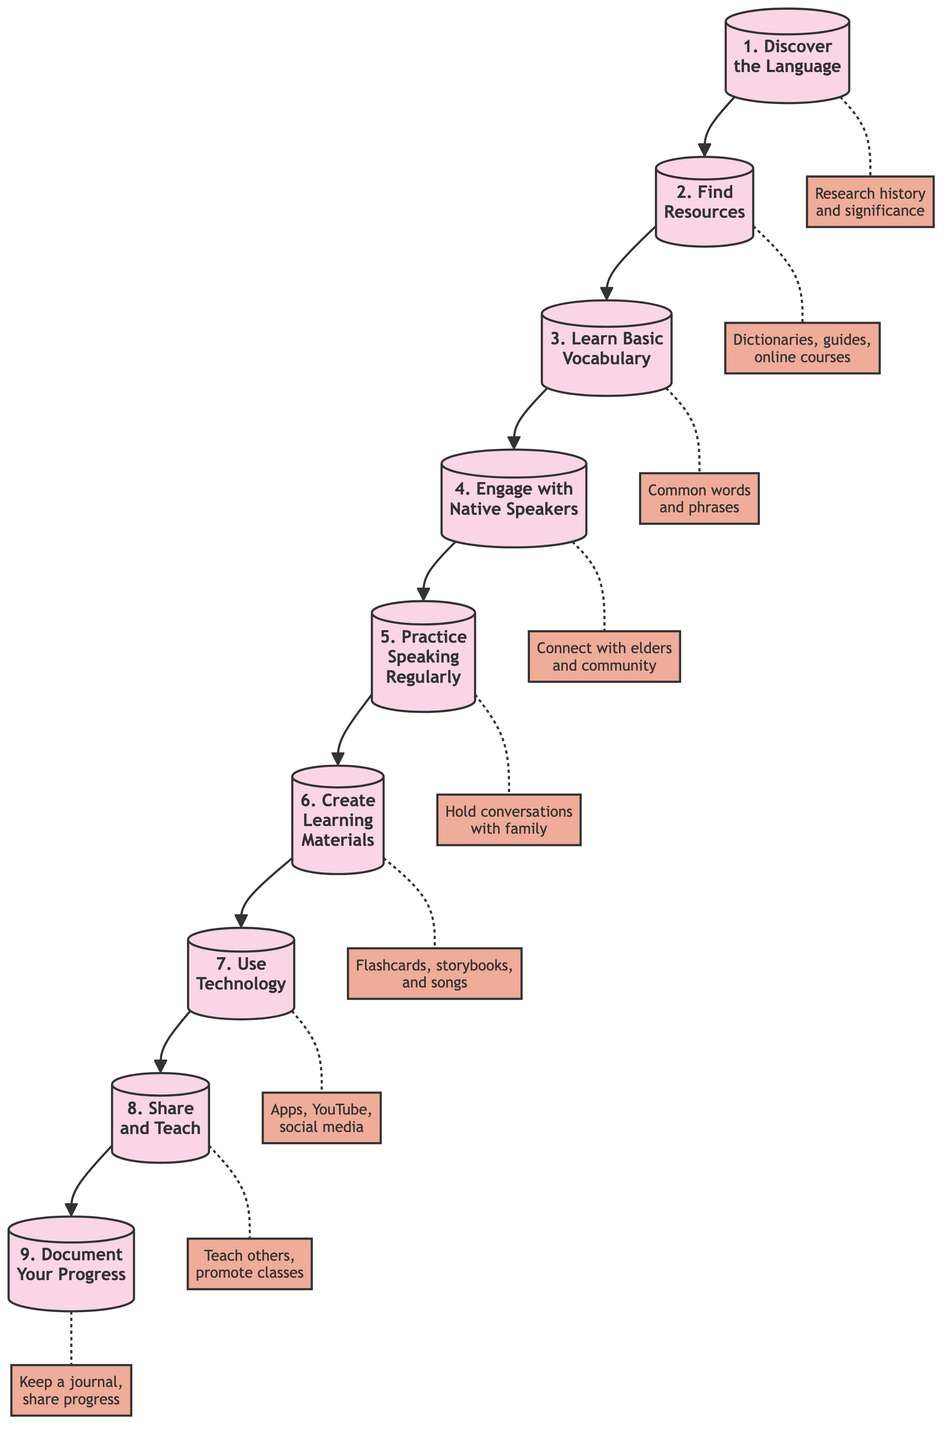What is the first step in the flow chart? The first node in the diagram is labeled "1. Discover the Language," indicating that this is the starting point of the process.
Answer: Discover the Language How many total steps are there in the flow chart? There are nine steps represented in the diagram, from "1. Discover the Language" to "9. Document Your Progress."
Answer: 9 Which step involves connecting with community members? Step "4. Engage with Native Speakers" explicitly mentions connecting with elders, family members, and community groups.
Answer: Engage with Native Speakers What follows after learning basic vocabulary? After step "3. Learn Basic Vocabulary," the next step is "4. Engage with Native Speakers" as indicated by the flow of the diagram.
Answer: Engage with Native Speakers What type of materials can you create in step six? Step "6. Create Learning Materials" specifies developing flashcards, storybooks, and songs in the Indigenous language.
Answer: Flashcards, storybooks, and songs What is the last step in the learning process according to the diagram? The final node is "9. Document Your Progress," which signifies the end of the learning trajectory outlined.
Answer: Document Your Progress Which step emphasizes the use of technology? Step "7. Use Technology" highlights the importance of utilizing apps, YouTube channels, and social media to aid in learning.
Answer: Use Technology What is the relationship between step two and step three? Step two, "2. Find Resources," directly leads to step three, "3. Learn Basic Vocabulary," indicating a sequential relationship where resources are found before vocabulary is learned.
Answer: Leads to What should be done to share your language learning with others? Step "8. Share and Teach" suggests teaching what you’ve learned to others and promoting language classes and cultural exchange programs.
Answer: Teach what you've learned 